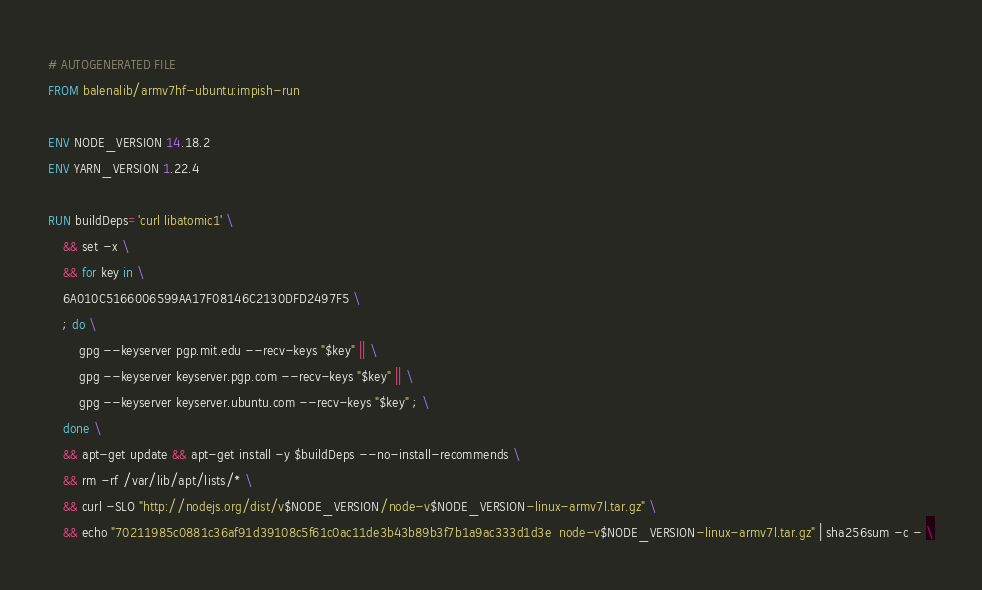<code> <loc_0><loc_0><loc_500><loc_500><_Dockerfile_># AUTOGENERATED FILE
FROM balenalib/armv7hf-ubuntu:impish-run

ENV NODE_VERSION 14.18.2
ENV YARN_VERSION 1.22.4

RUN buildDeps='curl libatomic1' \
	&& set -x \
	&& for key in \
	6A010C5166006599AA17F08146C2130DFD2497F5 \
	; do \
		gpg --keyserver pgp.mit.edu --recv-keys "$key" || \
		gpg --keyserver keyserver.pgp.com --recv-keys "$key" || \
		gpg --keyserver keyserver.ubuntu.com --recv-keys "$key" ; \
	done \
	&& apt-get update && apt-get install -y $buildDeps --no-install-recommends \
	&& rm -rf /var/lib/apt/lists/* \
	&& curl -SLO "http://nodejs.org/dist/v$NODE_VERSION/node-v$NODE_VERSION-linux-armv7l.tar.gz" \
	&& echo "70211985c0881c36af91d39108c5f61c0ac11de3b43b89b3f7b1a9ac333d1d3e  node-v$NODE_VERSION-linux-armv7l.tar.gz" | sha256sum -c - \</code> 